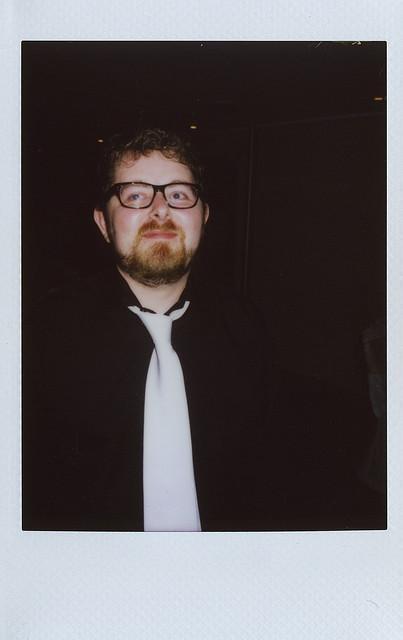How many people are in the picture?
Give a very brief answer. 1. How many sandwiches with orange paste are in the picture?
Give a very brief answer. 0. 